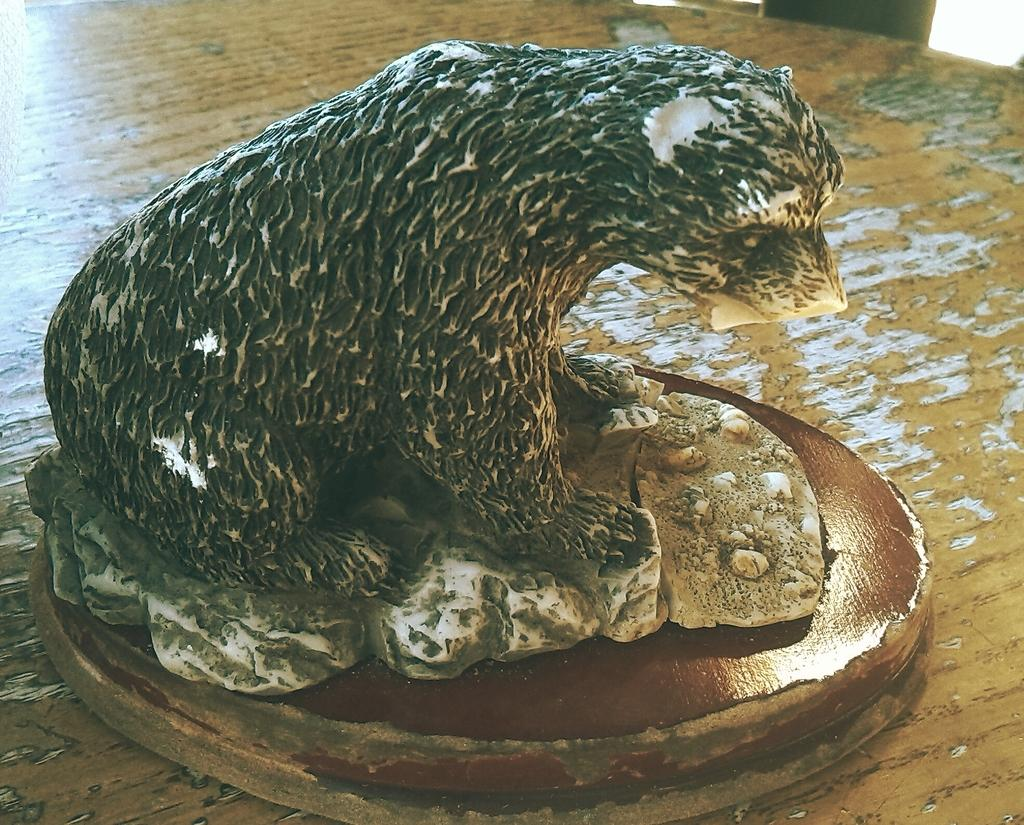What is the main subject of the image? There is a sculpture of an animal in the image. Where is the sculpture located in the image? The sculpture is on the floor. What thrill does the animal sculpture provide to the viewers in the image? There is no indication of any thrill provided by the animal sculpture in the image. The image only shows the sculpture on the floor. 